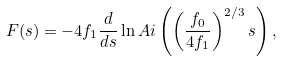Convert formula to latex. <formula><loc_0><loc_0><loc_500><loc_500>F ( s ) = - 4 f _ { 1 } \frac { d } { d s } \ln A i \left ( \left ( \frac { f _ { 0 } } { 4 f _ { 1 } } \right ) ^ { 2 / 3 } s \right ) ,</formula> 